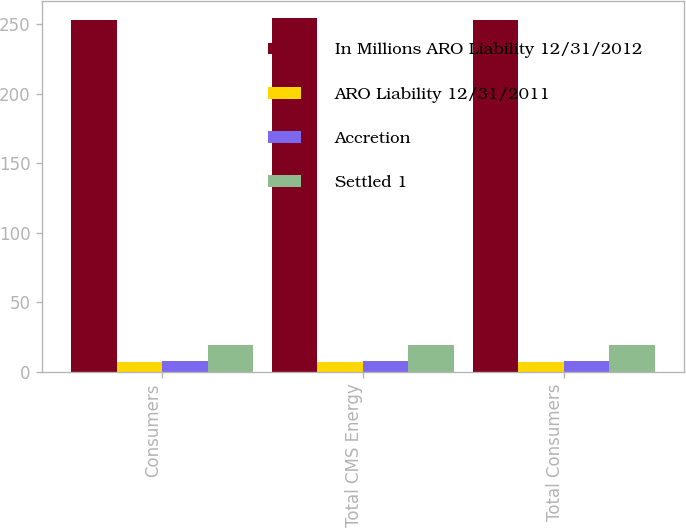<chart> <loc_0><loc_0><loc_500><loc_500><stacked_bar_chart><ecel><fcel>Consumers<fcel>Total CMS Energy<fcel>Total Consumers<nl><fcel>In Millions ARO Liability 12/31/2012<fcel>253<fcel>254<fcel>253<nl><fcel>ARO Liability 12/31/2011<fcel>7<fcel>7<fcel>7<nl><fcel>Accretion<fcel>8<fcel>8<fcel>8<nl><fcel>Settled 1<fcel>19<fcel>19<fcel>19<nl></chart> 